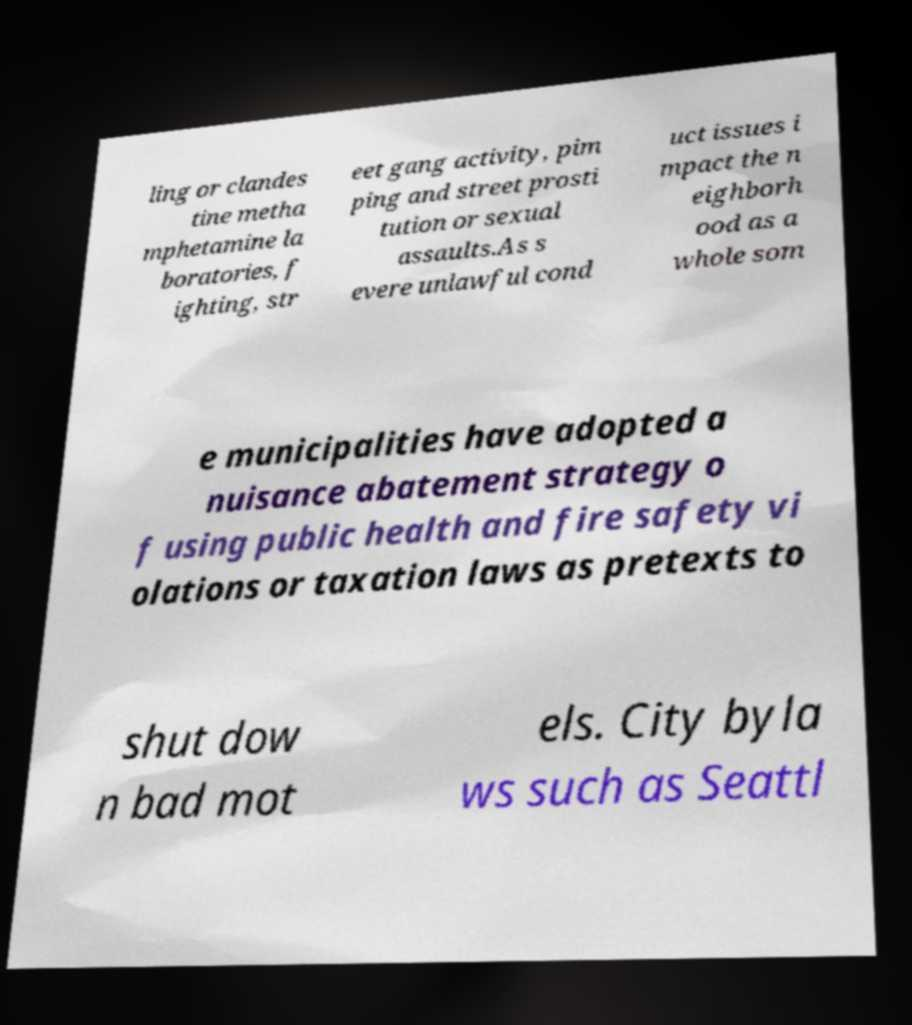Could you extract and type out the text from this image? ling or clandes tine metha mphetamine la boratories, f ighting, str eet gang activity, pim ping and street prosti tution or sexual assaults.As s evere unlawful cond uct issues i mpact the n eighborh ood as a whole som e municipalities have adopted a nuisance abatement strategy o f using public health and fire safety vi olations or taxation laws as pretexts to shut dow n bad mot els. City byla ws such as Seattl 